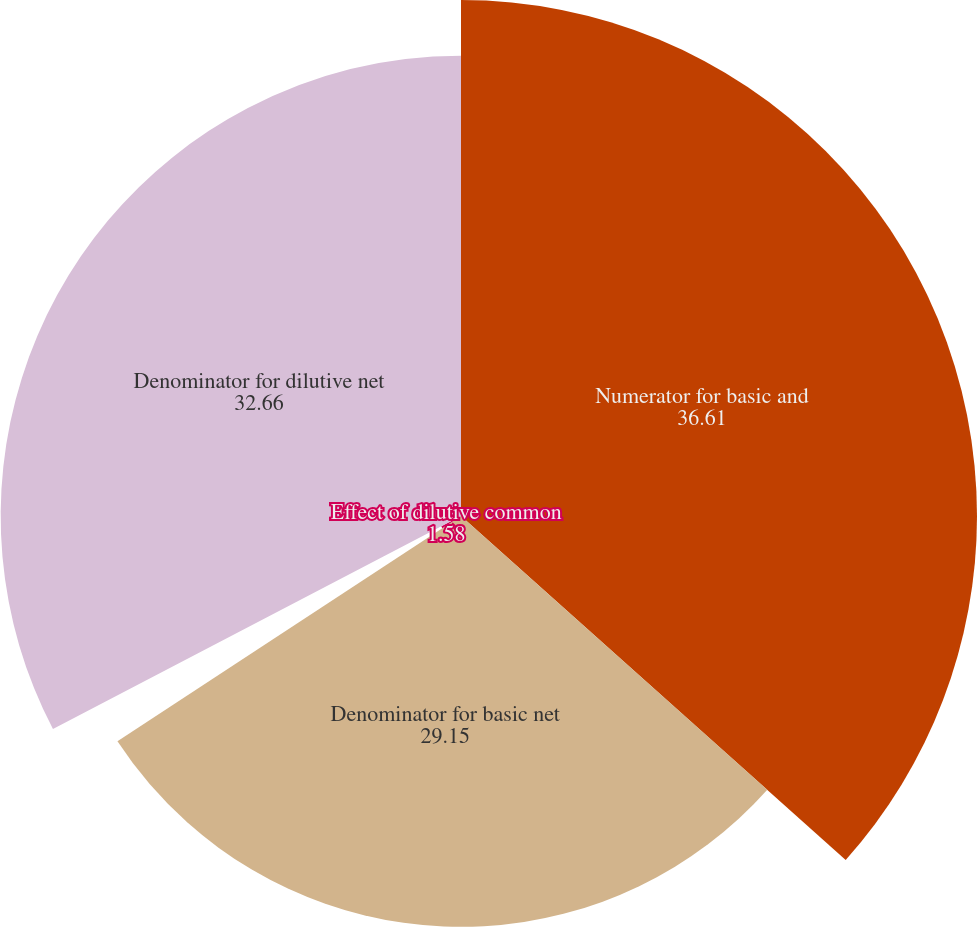Convert chart to OTSL. <chart><loc_0><loc_0><loc_500><loc_500><pie_chart><fcel>Numerator for basic and<fcel>Denominator for basic net<fcel>Effect of dilutive common<fcel>Denominator for dilutive net<nl><fcel>36.61%<fcel>29.15%<fcel>1.58%<fcel>32.66%<nl></chart> 